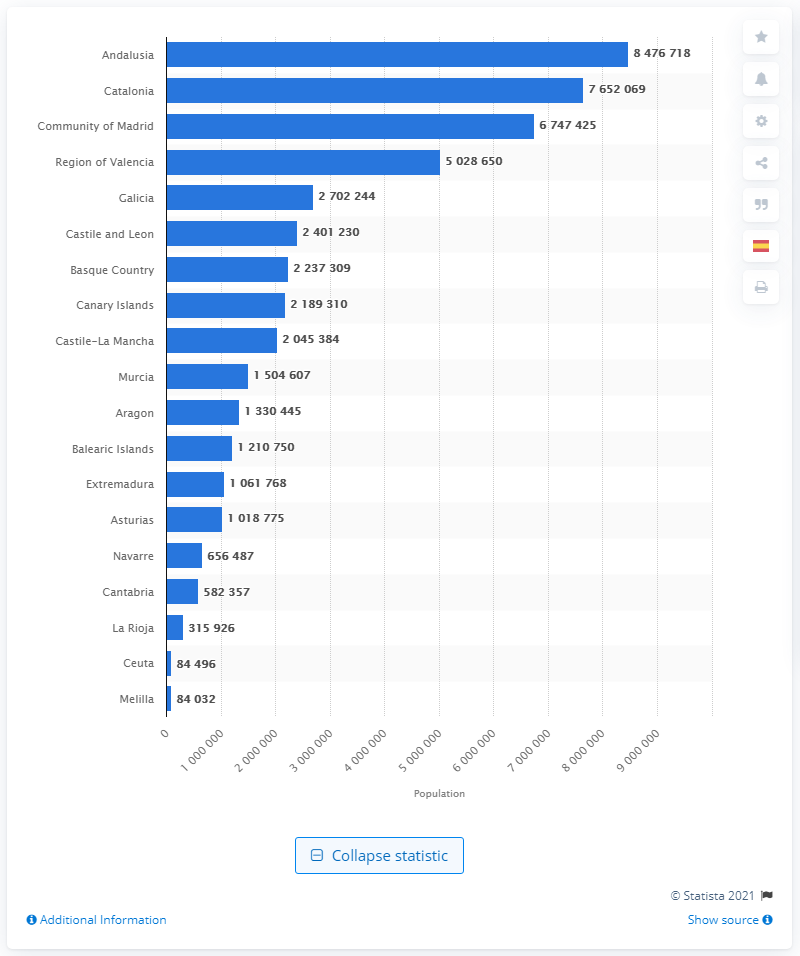Specify some key components in this picture. Andalusia was the most populous autonomous community in Spain in January of 2020. 